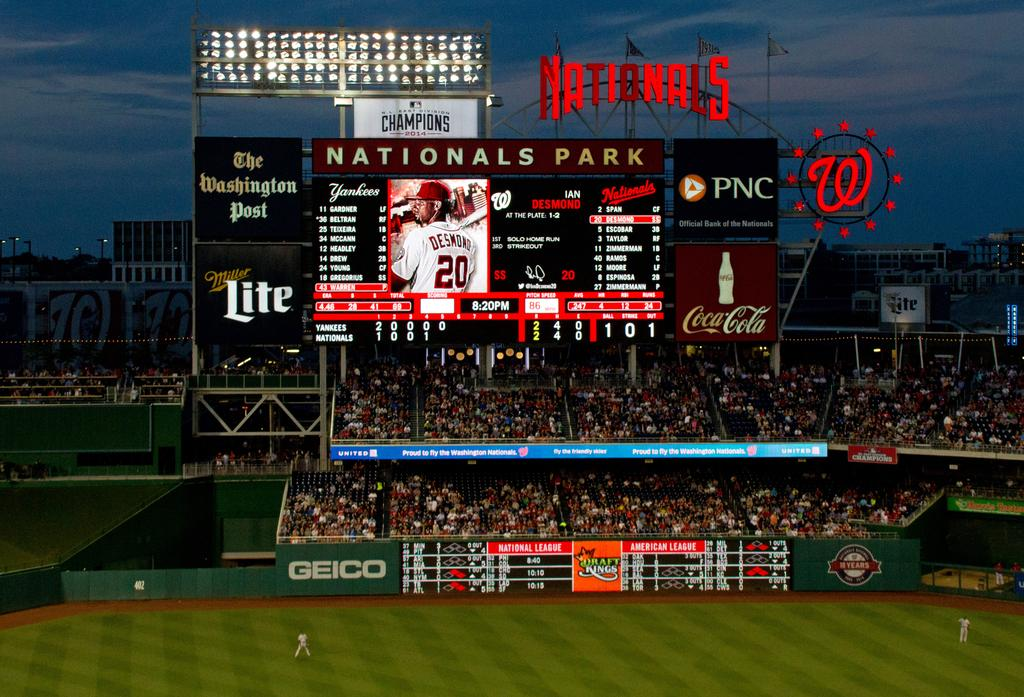<image>
Summarize the visual content of the image. a sports field with an illuminated board; the word Nationals is visible at the top 